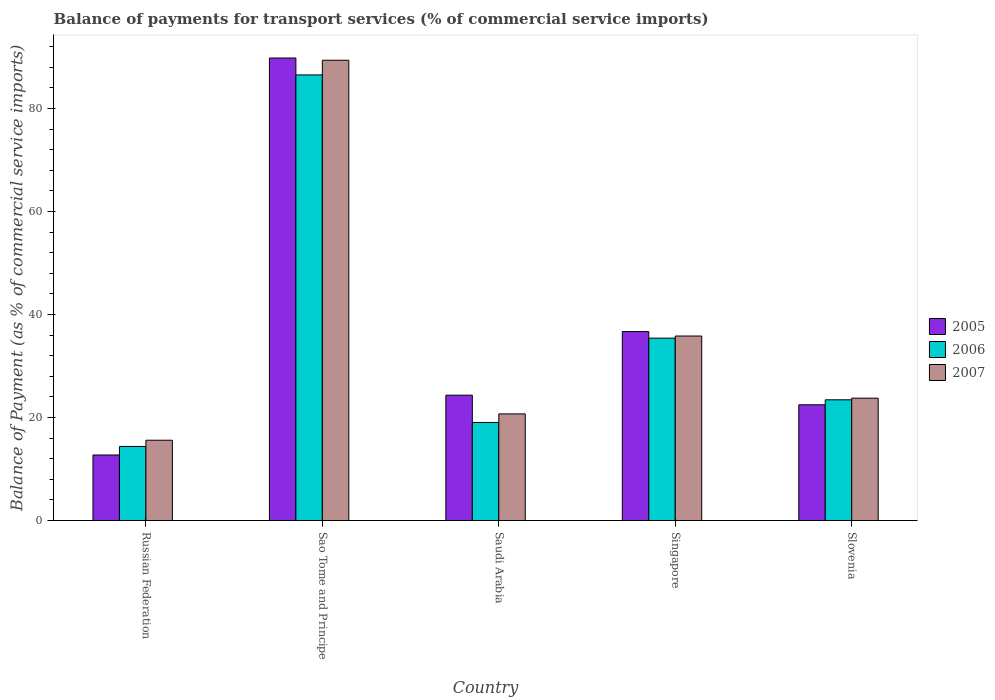How many different coloured bars are there?
Your response must be concise. 3. How many groups of bars are there?
Ensure brevity in your answer.  5. Are the number of bars on each tick of the X-axis equal?
Provide a short and direct response. Yes. How many bars are there on the 3rd tick from the left?
Your response must be concise. 3. What is the label of the 5th group of bars from the left?
Provide a succinct answer. Slovenia. In how many cases, is the number of bars for a given country not equal to the number of legend labels?
Your answer should be very brief. 0. What is the balance of payments for transport services in 2005 in Saudi Arabia?
Provide a succinct answer. 24.34. Across all countries, what is the maximum balance of payments for transport services in 2005?
Offer a very short reply. 89.8. Across all countries, what is the minimum balance of payments for transport services in 2007?
Offer a terse response. 15.6. In which country was the balance of payments for transport services in 2006 maximum?
Ensure brevity in your answer.  Sao Tome and Principe. In which country was the balance of payments for transport services in 2005 minimum?
Your answer should be compact. Russian Federation. What is the total balance of payments for transport services in 2005 in the graph?
Provide a succinct answer. 186.06. What is the difference between the balance of payments for transport services in 2005 in Sao Tome and Principe and that in Slovenia?
Your answer should be compact. 67.32. What is the difference between the balance of payments for transport services in 2006 in Slovenia and the balance of payments for transport services in 2005 in Saudi Arabia?
Your answer should be compact. -0.9. What is the average balance of payments for transport services in 2007 per country?
Give a very brief answer. 37.05. What is the difference between the balance of payments for transport services of/in 2005 and balance of payments for transport services of/in 2006 in Saudi Arabia?
Provide a succinct answer. 5.29. What is the ratio of the balance of payments for transport services in 2007 in Russian Federation to that in Sao Tome and Principe?
Your answer should be compact. 0.17. Is the balance of payments for transport services in 2005 in Sao Tome and Principe less than that in Saudi Arabia?
Your answer should be very brief. No. Is the difference between the balance of payments for transport services in 2005 in Saudi Arabia and Singapore greater than the difference between the balance of payments for transport services in 2006 in Saudi Arabia and Singapore?
Make the answer very short. Yes. What is the difference between the highest and the second highest balance of payments for transport services in 2005?
Offer a very short reply. -65.46. What is the difference between the highest and the lowest balance of payments for transport services in 2007?
Your answer should be very brief. 73.77. Is the sum of the balance of payments for transport services in 2005 in Russian Federation and Saudi Arabia greater than the maximum balance of payments for transport services in 2007 across all countries?
Provide a short and direct response. No. What does the 1st bar from the left in Sao Tome and Principe represents?
Ensure brevity in your answer.  2005. What does the 1st bar from the right in Russian Federation represents?
Your answer should be very brief. 2007. Is it the case that in every country, the sum of the balance of payments for transport services in 2007 and balance of payments for transport services in 2005 is greater than the balance of payments for transport services in 2006?
Provide a short and direct response. Yes. How many bars are there?
Your answer should be compact. 15. Are all the bars in the graph horizontal?
Provide a succinct answer. No. What is the difference between two consecutive major ticks on the Y-axis?
Give a very brief answer. 20. Does the graph contain any zero values?
Your answer should be compact. No. Does the graph contain grids?
Your answer should be compact. No. How many legend labels are there?
Make the answer very short. 3. What is the title of the graph?
Offer a terse response. Balance of payments for transport services (% of commercial service imports). Does "2012" appear as one of the legend labels in the graph?
Your answer should be compact. No. What is the label or title of the X-axis?
Offer a terse response. Country. What is the label or title of the Y-axis?
Ensure brevity in your answer.  Balance of Payment (as % of commercial service imports). What is the Balance of Payment (as % of commercial service imports) in 2005 in Russian Federation?
Offer a terse response. 12.73. What is the Balance of Payment (as % of commercial service imports) in 2006 in Russian Federation?
Your answer should be compact. 14.39. What is the Balance of Payment (as % of commercial service imports) in 2007 in Russian Federation?
Give a very brief answer. 15.6. What is the Balance of Payment (as % of commercial service imports) in 2005 in Sao Tome and Principe?
Provide a short and direct response. 89.8. What is the Balance of Payment (as % of commercial service imports) in 2006 in Sao Tome and Principe?
Keep it short and to the point. 86.52. What is the Balance of Payment (as % of commercial service imports) in 2007 in Sao Tome and Principe?
Provide a short and direct response. 89.37. What is the Balance of Payment (as % of commercial service imports) of 2005 in Saudi Arabia?
Give a very brief answer. 24.34. What is the Balance of Payment (as % of commercial service imports) in 2006 in Saudi Arabia?
Offer a very short reply. 19.05. What is the Balance of Payment (as % of commercial service imports) in 2007 in Saudi Arabia?
Your answer should be very brief. 20.71. What is the Balance of Payment (as % of commercial service imports) of 2005 in Singapore?
Provide a short and direct response. 36.69. What is the Balance of Payment (as % of commercial service imports) of 2006 in Singapore?
Offer a terse response. 35.42. What is the Balance of Payment (as % of commercial service imports) of 2007 in Singapore?
Give a very brief answer. 35.83. What is the Balance of Payment (as % of commercial service imports) in 2005 in Slovenia?
Offer a very short reply. 22.48. What is the Balance of Payment (as % of commercial service imports) in 2006 in Slovenia?
Your response must be concise. 23.45. What is the Balance of Payment (as % of commercial service imports) of 2007 in Slovenia?
Make the answer very short. 23.76. Across all countries, what is the maximum Balance of Payment (as % of commercial service imports) in 2005?
Keep it short and to the point. 89.8. Across all countries, what is the maximum Balance of Payment (as % of commercial service imports) of 2006?
Offer a terse response. 86.52. Across all countries, what is the maximum Balance of Payment (as % of commercial service imports) of 2007?
Your response must be concise. 89.37. Across all countries, what is the minimum Balance of Payment (as % of commercial service imports) of 2005?
Provide a succinct answer. 12.73. Across all countries, what is the minimum Balance of Payment (as % of commercial service imports) of 2006?
Offer a very short reply. 14.39. Across all countries, what is the minimum Balance of Payment (as % of commercial service imports) in 2007?
Your response must be concise. 15.6. What is the total Balance of Payment (as % of commercial service imports) of 2005 in the graph?
Your answer should be very brief. 186.06. What is the total Balance of Payment (as % of commercial service imports) of 2006 in the graph?
Your answer should be very brief. 178.83. What is the total Balance of Payment (as % of commercial service imports) of 2007 in the graph?
Offer a terse response. 185.27. What is the difference between the Balance of Payment (as % of commercial service imports) of 2005 in Russian Federation and that in Sao Tome and Principe?
Ensure brevity in your answer.  -77.07. What is the difference between the Balance of Payment (as % of commercial service imports) of 2006 in Russian Federation and that in Sao Tome and Principe?
Your answer should be very brief. -72.13. What is the difference between the Balance of Payment (as % of commercial service imports) in 2007 in Russian Federation and that in Sao Tome and Principe?
Offer a terse response. -73.77. What is the difference between the Balance of Payment (as % of commercial service imports) in 2005 in Russian Federation and that in Saudi Arabia?
Make the answer very short. -11.61. What is the difference between the Balance of Payment (as % of commercial service imports) in 2006 in Russian Federation and that in Saudi Arabia?
Keep it short and to the point. -4.66. What is the difference between the Balance of Payment (as % of commercial service imports) of 2007 in Russian Federation and that in Saudi Arabia?
Keep it short and to the point. -5.11. What is the difference between the Balance of Payment (as % of commercial service imports) of 2005 in Russian Federation and that in Singapore?
Keep it short and to the point. -23.96. What is the difference between the Balance of Payment (as % of commercial service imports) of 2006 in Russian Federation and that in Singapore?
Your answer should be compact. -21.03. What is the difference between the Balance of Payment (as % of commercial service imports) of 2007 in Russian Federation and that in Singapore?
Your response must be concise. -20.23. What is the difference between the Balance of Payment (as % of commercial service imports) of 2005 in Russian Federation and that in Slovenia?
Provide a short and direct response. -9.75. What is the difference between the Balance of Payment (as % of commercial service imports) of 2006 in Russian Federation and that in Slovenia?
Your answer should be very brief. -9.06. What is the difference between the Balance of Payment (as % of commercial service imports) of 2007 in Russian Federation and that in Slovenia?
Your answer should be very brief. -8.16. What is the difference between the Balance of Payment (as % of commercial service imports) of 2005 in Sao Tome and Principe and that in Saudi Arabia?
Offer a terse response. 65.46. What is the difference between the Balance of Payment (as % of commercial service imports) in 2006 in Sao Tome and Principe and that in Saudi Arabia?
Keep it short and to the point. 67.47. What is the difference between the Balance of Payment (as % of commercial service imports) in 2007 in Sao Tome and Principe and that in Saudi Arabia?
Give a very brief answer. 68.66. What is the difference between the Balance of Payment (as % of commercial service imports) in 2005 in Sao Tome and Principe and that in Singapore?
Your answer should be very brief. 53.11. What is the difference between the Balance of Payment (as % of commercial service imports) in 2006 in Sao Tome and Principe and that in Singapore?
Ensure brevity in your answer.  51.1. What is the difference between the Balance of Payment (as % of commercial service imports) in 2007 in Sao Tome and Principe and that in Singapore?
Offer a very short reply. 53.54. What is the difference between the Balance of Payment (as % of commercial service imports) of 2005 in Sao Tome and Principe and that in Slovenia?
Give a very brief answer. 67.32. What is the difference between the Balance of Payment (as % of commercial service imports) of 2006 in Sao Tome and Principe and that in Slovenia?
Offer a very short reply. 63.07. What is the difference between the Balance of Payment (as % of commercial service imports) in 2007 in Sao Tome and Principe and that in Slovenia?
Offer a very short reply. 65.61. What is the difference between the Balance of Payment (as % of commercial service imports) in 2005 in Saudi Arabia and that in Singapore?
Your answer should be very brief. -12.35. What is the difference between the Balance of Payment (as % of commercial service imports) in 2006 in Saudi Arabia and that in Singapore?
Provide a short and direct response. -16.37. What is the difference between the Balance of Payment (as % of commercial service imports) of 2007 in Saudi Arabia and that in Singapore?
Your answer should be compact. -15.12. What is the difference between the Balance of Payment (as % of commercial service imports) in 2005 in Saudi Arabia and that in Slovenia?
Your answer should be very brief. 1.86. What is the difference between the Balance of Payment (as % of commercial service imports) of 2006 in Saudi Arabia and that in Slovenia?
Your answer should be very brief. -4.4. What is the difference between the Balance of Payment (as % of commercial service imports) in 2007 in Saudi Arabia and that in Slovenia?
Provide a short and direct response. -3.05. What is the difference between the Balance of Payment (as % of commercial service imports) in 2005 in Singapore and that in Slovenia?
Give a very brief answer. 14.21. What is the difference between the Balance of Payment (as % of commercial service imports) of 2006 in Singapore and that in Slovenia?
Provide a succinct answer. 11.97. What is the difference between the Balance of Payment (as % of commercial service imports) of 2007 in Singapore and that in Slovenia?
Offer a very short reply. 12.07. What is the difference between the Balance of Payment (as % of commercial service imports) in 2005 in Russian Federation and the Balance of Payment (as % of commercial service imports) in 2006 in Sao Tome and Principe?
Make the answer very short. -73.79. What is the difference between the Balance of Payment (as % of commercial service imports) of 2005 in Russian Federation and the Balance of Payment (as % of commercial service imports) of 2007 in Sao Tome and Principe?
Offer a terse response. -76.64. What is the difference between the Balance of Payment (as % of commercial service imports) in 2006 in Russian Federation and the Balance of Payment (as % of commercial service imports) in 2007 in Sao Tome and Principe?
Give a very brief answer. -74.98. What is the difference between the Balance of Payment (as % of commercial service imports) in 2005 in Russian Federation and the Balance of Payment (as % of commercial service imports) in 2006 in Saudi Arabia?
Offer a very short reply. -6.32. What is the difference between the Balance of Payment (as % of commercial service imports) of 2005 in Russian Federation and the Balance of Payment (as % of commercial service imports) of 2007 in Saudi Arabia?
Offer a very short reply. -7.98. What is the difference between the Balance of Payment (as % of commercial service imports) in 2006 in Russian Federation and the Balance of Payment (as % of commercial service imports) in 2007 in Saudi Arabia?
Offer a terse response. -6.32. What is the difference between the Balance of Payment (as % of commercial service imports) in 2005 in Russian Federation and the Balance of Payment (as % of commercial service imports) in 2006 in Singapore?
Provide a succinct answer. -22.69. What is the difference between the Balance of Payment (as % of commercial service imports) of 2005 in Russian Federation and the Balance of Payment (as % of commercial service imports) of 2007 in Singapore?
Provide a succinct answer. -23.1. What is the difference between the Balance of Payment (as % of commercial service imports) in 2006 in Russian Federation and the Balance of Payment (as % of commercial service imports) in 2007 in Singapore?
Give a very brief answer. -21.44. What is the difference between the Balance of Payment (as % of commercial service imports) of 2005 in Russian Federation and the Balance of Payment (as % of commercial service imports) of 2006 in Slovenia?
Ensure brevity in your answer.  -10.71. What is the difference between the Balance of Payment (as % of commercial service imports) of 2005 in Russian Federation and the Balance of Payment (as % of commercial service imports) of 2007 in Slovenia?
Provide a short and direct response. -11.03. What is the difference between the Balance of Payment (as % of commercial service imports) of 2006 in Russian Federation and the Balance of Payment (as % of commercial service imports) of 2007 in Slovenia?
Provide a short and direct response. -9.37. What is the difference between the Balance of Payment (as % of commercial service imports) in 2005 in Sao Tome and Principe and the Balance of Payment (as % of commercial service imports) in 2006 in Saudi Arabia?
Your answer should be very brief. 70.75. What is the difference between the Balance of Payment (as % of commercial service imports) of 2005 in Sao Tome and Principe and the Balance of Payment (as % of commercial service imports) of 2007 in Saudi Arabia?
Your response must be concise. 69.09. What is the difference between the Balance of Payment (as % of commercial service imports) of 2006 in Sao Tome and Principe and the Balance of Payment (as % of commercial service imports) of 2007 in Saudi Arabia?
Ensure brevity in your answer.  65.81. What is the difference between the Balance of Payment (as % of commercial service imports) of 2005 in Sao Tome and Principe and the Balance of Payment (as % of commercial service imports) of 2006 in Singapore?
Your answer should be compact. 54.39. What is the difference between the Balance of Payment (as % of commercial service imports) in 2005 in Sao Tome and Principe and the Balance of Payment (as % of commercial service imports) in 2007 in Singapore?
Make the answer very short. 53.97. What is the difference between the Balance of Payment (as % of commercial service imports) of 2006 in Sao Tome and Principe and the Balance of Payment (as % of commercial service imports) of 2007 in Singapore?
Offer a terse response. 50.69. What is the difference between the Balance of Payment (as % of commercial service imports) in 2005 in Sao Tome and Principe and the Balance of Payment (as % of commercial service imports) in 2006 in Slovenia?
Give a very brief answer. 66.36. What is the difference between the Balance of Payment (as % of commercial service imports) of 2005 in Sao Tome and Principe and the Balance of Payment (as % of commercial service imports) of 2007 in Slovenia?
Offer a very short reply. 66.04. What is the difference between the Balance of Payment (as % of commercial service imports) in 2006 in Sao Tome and Principe and the Balance of Payment (as % of commercial service imports) in 2007 in Slovenia?
Your answer should be compact. 62.76. What is the difference between the Balance of Payment (as % of commercial service imports) in 2005 in Saudi Arabia and the Balance of Payment (as % of commercial service imports) in 2006 in Singapore?
Ensure brevity in your answer.  -11.07. What is the difference between the Balance of Payment (as % of commercial service imports) of 2005 in Saudi Arabia and the Balance of Payment (as % of commercial service imports) of 2007 in Singapore?
Offer a very short reply. -11.49. What is the difference between the Balance of Payment (as % of commercial service imports) in 2006 in Saudi Arabia and the Balance of Payment (as % of commercial service imports) in 2007 in Singapore?
Provide a short and direct response. -16.78. What is the difference between the Balance of Payment (as % of commercial service imports) of 2005 in Saudi Arabia and the Balance of Payment (as % of commercial service imports) of 2006 in Slovenia?
Offer a very short reply. 0.9. What is the difference between the Balance of Payment (as % of commercial service imports) in 2005 in Saudi Arabia and the Balance of Payment (as % of commercial service imports) in 2007 in Slovenia?
Make the answer very short. 0.58. What is the difference between the Balance of Payment (as % of commercial service imports) of 2006 in Saudi Arabia and the Balance of Payment (as % of commercial service imports) of 2007 in Slovenia?
Your answer should be very brief. -4.71. What is the difference between the Balance of Payment (as % of commercial service imports) in 2005 in Singapore and the Balance of Payment (as % of commercial service imports) in 2006 in Slovenia?
Give a very brief answer. 13.25. What is the difference between the Balance of Payment (as % of commercial service imports) of 2005 in Singapore and the Balance of Payment (as % of commercial service imports) of 2007 in Slovenia?
Your answer should be very brief. 12.93. What is the difference between the Balance of Payment (as % of commercial service imports) in 2006 in Singapore and the Balance of Payment (as % of commercial service imports) in 2007 in Slovenia?
Provide a short and direct response. 11.66. What is the average Balance of Payment (as % of commercial service imports) in 2005 per country?
Your answer should be compact. 37.21. What is the average Balance of Payment (as % of commercial service imports) of 2006 per country?
Offer a terse response. 35.77. What is the average Balance of Payment (as % of commercial service imports) of 2007 per country?
Provide a succinct answer. 37.05. What is the difference between the Balance of Payment (as % of commercial service imports) of 2005 and Balance of Payment (as % of commercial service imports) of 2006 in Russian Federation?
Your answer should be very brief. -1.66. What is the difference between the Balance of Payment (as % of commercial service imports) of 2005 and Balance of Payment (as % of commercial service imports) of 2007 in Russian Federation?
Provide a short and direct response. -2.87. What is the difference between the Balance of Payment (as % of commercial service imports) in 2006 and Balance of Payment (as % of commercial service imports) in 2007 in Russian Federation?
Your response must be concise. -1.21. What is the difference between the Balance of Payment (as % of commercial service imports) in 2005 and Balance of Payment (as % of commercial service imports) in 2006 in Sao Tome and Principe?
Your response must be concise. 3.28. What is the difference between the Balance of Payment (as % of commercial service imports) in 2005 and Balance of Payment (as % of commercial service imports) in 2007 in Sao Tome and Principe?
Keep it short and to the point. 0.43. What is the difference between the Balance of Payment (as % of commercial service imports) of 2006 and Balance of Payment (as % of commercial service imports) of 2007 in Sao Tome and Principe?
Offer a terse response. -2.85. What is the difference between the Balance of Payment (as % of commercial service imports) in 2005 and Balance of Payment (as % of commercial service imports) in 2006 in Saudi Arabia?
Ensure brevity in your answer.  5.29. What is the difference between the Balance of Payment (as % of commercial service imports) of 2005 and Balance of Payment (as % of commercial service imports) of 2007 in Saudi Arabia?
Offer a terse response. 3.63. What is the difference between the Balance of Payment (as % of commercial service imports) in 2006 and Balance of Payment (as % of commercial service imports) in 2007 in Saudi Arabia?
Give a very brief answer. -1.66. What is the difference between the Balance of Payment (as % of commercial service imports) of 2005 and Balance of Payment (as % of commercial service imports) of 2006 in Singapore?
Give a very brief answer. 1.28. What is the difference between the Balance of Payment (as % of commercial service imports) of 2005 and Balance of Payment (as % of commercial service imports) of 2007 in Singapore?
Offer a very short reply. 0.86. What is the difference between the Balance of Payment (as % of commercial service imports) in 2006 and Balance of Payment (as % of commercial service imports) in 2007 in Singapore?
Provide a short and direct response. -0.41. What is the difference between the Balance of Payment (as % of commercial service imports) in 2005 and Balance of Payment (as % of commercial service imports) in 2006 in Slovenia?
Your response must be concise. -0.97. What is the difference between the Balance of Payment (as % of commercial service imports) in 2005 and Balance of Payment (as % of commercial service imports) in 2007 in Slovenia?
Ensure brevity in your answer.  -1.28. What is the difference between the Balance of Payment (as % of commercial service imports) of 2006 and Balance of Payment (as % of commercial service imports) of 2007 in Slovenia?
Your answer should be very brief. -0.31. What is the ratio of the Balance of Payment (as % of commercial service imports) in 2005 in Russian Federation to that in Sao Tome and Principe?
Ensure brevity in your answer.  0.14. What is the ratio of the Balance of Payment (as % of commercial service imports) in 2006 in Russian Federation to that in Sao Tome and Principe?
Ensure brevity in your answer.  0.17. What is the ratio of the Balance of Payment (as % of commercial service imports) of 2007 in Russian Federation to that in Sao Tome and Principe?
Ensure brevity in your answer.  0.17. What is the ratio of the Balance of Payment (as % of commercial service imports) in 2005 in Russian Federation to that in Saudi Arabia?
Your answer should be compact. 0.52. What is the ratio of the Balance of Payment (as % of commercial service imports) in 2006 in Russian Federation to that in Saudi Arabia?
Your answer should be compact. 0.76. What is the ratio of the Balance of Payment (as % of commercial service imports) in 2007 in Russian Federation to that in Saudi Arabia?
Provide a succinct answer. 0.75. What is the ratio of the Balance of Payment (as % of commercial service imports) of 2005 in Russian Federation to that in Singapore?
Make the answer very short. 0.35. What is the ratio of the Balance of Payment (as % of commercial service imports) in 2006 in Russian Federation to that in Singapore?
Keep it short and to the point. 0.41. What is the ratio of the Balance of Payment (as % of commercial service imports) of 2007 in Russian Federation to that in Singapore?
Offer a very short reply. 0.44. What is the ratio of the Balance of Payment (as % of commercial service imports) in 2005 in Russian Federation to that in Slovenia?
Provide a short and direct response. 0.57. What is the ratio of the Balance of Payment (as % of commercial service imports) of 2006 in Russian Federation to that in Slovenia?
Offer a terse response. 0.61. What is the ratio of the Balance of Payment (as % of commercial service imports) of 2007 in Russian Federation to that in Slovenia?
Offer a very short reply. 0.66. What is the ratio of the Balance of Payment (as % of commercial service imports) of 2005 in Sao Tome and Principe to that in Saudi Arabia?
Ensure brevity in your answer.  3.69. What is the ratio of the Balance of Payment (as % of commercial service imports) in 2006 in Sao Tome and Principe to that in Saudi Arabia?
Your answer should be very brief. 4.54. What is the ratio of the Balance of Payment (as % of commercial service imports) of 2007 in Sao Tome and Principe to that in Saudi Arabia?
Offer a terse response. 4.32. What is the ratio of the Balance of Payment (as % of commercial service imports) in 2005 in Sao Tome and Principe to that in Singapore?
Ensure brevity in your answer.  2.45. What is the ratio of the Balance of Payment (as % of commercial service imports) in 2006 in Sao Tome and Principe to that in Singapore?
Offer a terse response. 2.44. What is the ratio of the Balance of Payment (as % of commercial service imports) of 2007 in Sao Tome and Principe to that in Singapore?
Your answer should be very brief. 2.49. What is the ratio of the Balance of Payment (as % of commercial service imports) in 2005 in Sao Tome and Principe to that in Slovenia?
Provide a succinct answer. 3.99. What is the ratio of the Balance of Payment (as % of commercial service imports) in 2006 in Sao Tome and Principe to that in Slovenia?
Provide a short and direct response. 3.69. What is the ratio of the Balance of Payment (as % of commercial service imports) in 2007 in Sao Tome and Principe to that in Slovenia?
Your answer should be very brief. 3.76. What is the ratio of the Balance of Payment (as % of commercial service imports) in 2005 in Saudi Arabia to that in Singapore?
Make the answer very short. 0.66. What is the ratio of the Balance of Payment (as % of commercial service imports) of 2006 in Saudi Arabia to that in Singapore?
Offer a very short reply. 0.54. What is the ratio of the Balance of Payment (as % of commercial service imports) in 2007 in Saudi Arabia to that in Singapore?
Keep it short and to the point. 0.58. What is the ratio of the Balance of Payment (as % of commercial service imports) of 2005 in Saudi Arabia to that in Slovenia?
Offer a very short reply. 1.08. What is the ratio of the Balance of Payment (as % of commercial service imports) of 2006 in Saudi Arabia to that in Slovenia?
Provide a succinct answer. 0.81. What is the ratio of the Balance of Payment (as % of commercial service imports) in 2007 in Saudi Arabia to that in Slovenia?
Provide a short and direct response. 0.87. What is the ratio of the Balance of Payment (as % of commercial service imports) of 2005 in Singapore to that in Slovenia?
Give a very brief answer. 1.63. What is the ratio of the Balance of Payment (as % of commercial service imports) of 2006 in Singapore to that in Slovenia?
Make the answer very short. 1.51. What is the ratio of the Balance of Payment (as % of commercial service imports) of 2007 in Singapore to that in Slovenia?
Give a very brief answer. 1.51. What is the difference between the highest and the second highest Balance of Payment (as % of commercial service imports) of 2005?
Ensure brevity in your answer.  53.11. What is the difference between the highest and the second highest Balance of Payment (as % of commercial service imports) of 2006?
Your answer should be very brief. 51.1. What is the difference between the highest and the second highest Balance of Payment (as % of commercial service imports) in 2007?
Ensure brevity in your answer.  53.54. What is the difference between the highest and the lowest Balance of Payment (as % of commercial service imports) in 2005?
Provide a short and direct response. 77.07. What is the difference between the highest and the lowest Balance of Payment (as % of commercial service imports) in 2006?
Make the answer very short. 72.13. What is the difference between the highest and the lowest Balance of Payment (as % of commercial service imports) of 2007?
Your response must be concise. 73.77. 